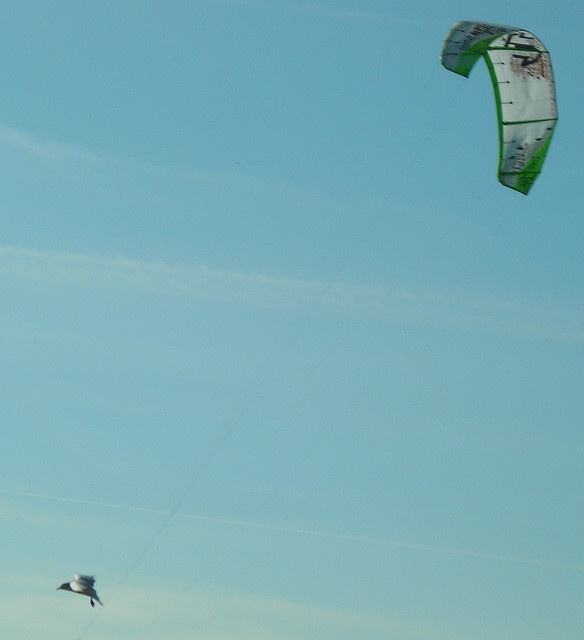Describe the objects in this image and their specific colors. I can see kite in lightblue, darkgray, gray, teal, and darkgreen tones and bird in lightblue, gray, blue, darkgray, and black tones in this image. 